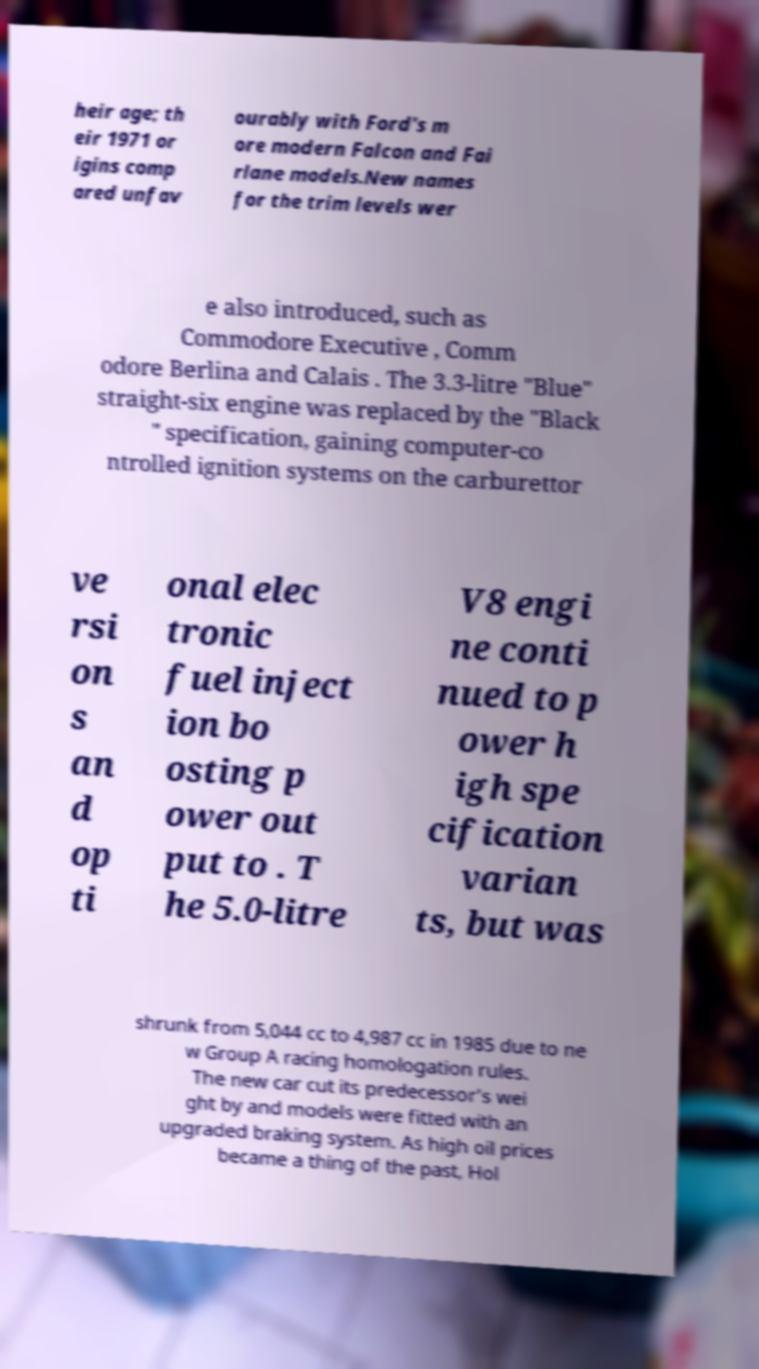Can you accurately transcribe the text from the provided image for me? heir age; th eir 1971 or igins comp ared unfav ourably with Ford's m ore modern Falcon and Fai rlane models.New names for the trim levels wer e also introduced, such as Commodore Executive , Comm odore Berlina and Calais . The 3.3-litre "Blue" straight-six engine was replaced by the "Black " specification, gaining computer-co ntrolled ignition systems on the carburettor ve rsi on s an d op ti onal elec tronic fuel inject ion bo osting p ower out put to . T he 5.0-litre V8 engi ne conti nued to p ower h igh spe cification varian ts, but was shrunk from 5,044 cc to 4,987 cc in 1985 due to ne w Group A racing homologation rules. The new car cut its predecessor's wei ght by and models were fitted with an upgraded braking system. As high oil prices became a thing of the past, Hol 